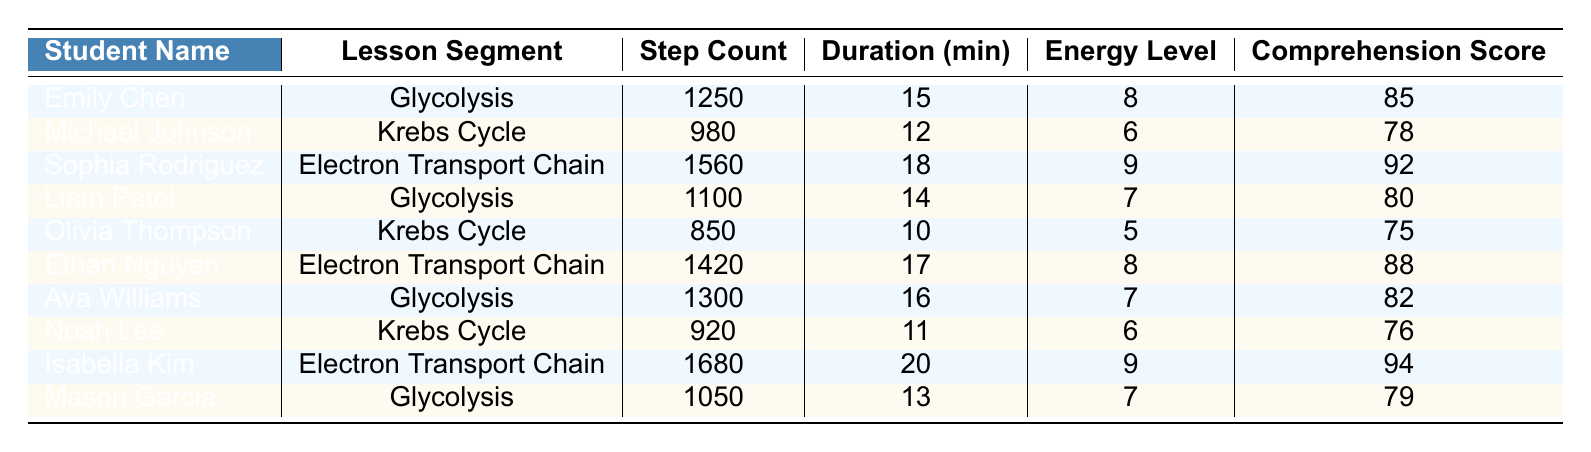What is the step count of Sophia Rodriguez during the Electron Transport Chain lesson? The table shows that Sophia Rodriguez has a step count of 1560 during the Electron Transport Chain lesson.
Answer: 1560 Which student had the highest energy level? By comparing the energy levels of all students in the table, Sophia Rodriguez has the highest energy level of 9.
Answer: Sophia Rodriguez What is the total step count for all lessons? Summing the step counts from all students gives (1250 + 980 + 1560 + 1100 + 850 + 1420 + 1300 + 920 + 1680 + 1050) = 10310.
Answer: 10310 Which lesson segment had the most steps recorded, and what was the count? By checking the step counts per lesson segment, the Electron Transport Chain had the highest step count, specifically 1680 from Isabella Kim.
Answer: Electron Transport Chain, 1680 What is the average step count of all students during the Glycolysis lessons? The step counts for Glycolysis are 1250, 1100, 1300, and 1050. The average is calculated as (1250 + 1100 + 1300 + 1050) / 4 = 1150.
Answer: 1150 Are there any students who achieved an energy level of 5? Yes, according to the table, Olivia Thompson has an energy level of 5.
Answer: Yes Who had a step count less than the average step count of the entire group? The average step count can be calculated as 10310 (total) divided by 10 (number of students) which is 1031. Looking at the individual counts, both Michael Johnson (980) and Olivia Thompson (850) are below this average.
Answer: Michael Johnson, Olivia Thompson What is the difference in step counts between the highest and lowest achieving students? The highest step count is 1680 (Isabella Kim) and the lowest is 850 (Olivia Thompson). The difference is 1680 - 850 = 830.
Answer: 830 How does the comprehension score correlate with energy levels among students? A quick review of the two columns shows that students with higher energy levels tend to have higher comprehension scores. For example, Sophia Rodriguez has energy level 9 and a score of 92, while Olivia Thompson has energy level 5 and a score of 75.
Answer: Positive correlation What is the median duration of lessons attended by the students? The durations listed are 15, 12, 18, 14, 10, 17, 16, 11, 20, and 13. Arranging these in order gives 10, 11, 12, 13, 14, 15, 16, 17, 18, 20. The median, being the average of the 5th and 6th values (14 and 15), is (14 + 15) / 2 = 14.5.
Answer: 14.5 